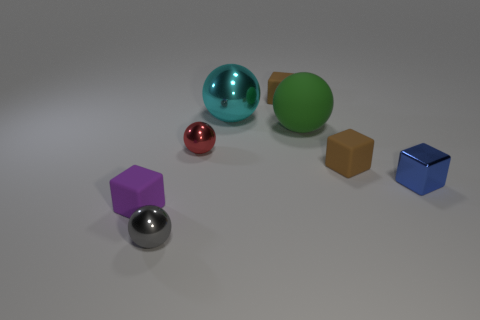Is there a red thing that has the same material as the big cyan ball?
Offer a terse response. Yes. What is the green ball made of?
Provide a short and direct response. Rubber. There is a tiny object that is to the left of the tiny metallic sphere that is in front of the block that is to the left of the small gray sphere; what is its shape?
Provide a succinct answer. Cube. Is the number of rubber cubes that are on the right side of the small gray shiny ball greater than the number of big green things?
Your answer should be compact. Yes. Do the gray shiny thing and the cyan metal object right of the gray metal object have the same shape?
Your response must be concise. Yes. How many cyan metallic spheres are in front of the ball that is in front of the small matte block that is left of the tiny gray metallic ball?
Offer a terse response. 0. What color is the other metallic cube that is the same size as the purple cube?
Make the answer very short. Blue. There is a rubber thing that is to the left of the small metal sphere that is in front of the purple cube; how big is it?
Ensure brevity in your answer.  Small. What number of other objects are the same size as the purple matte thing?
Your answer should be very brief. 5. How many purple blocks are there?
Give a very brief answer. 1. 